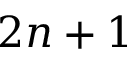Convert formula to latex. <formula><loc_0><loc_0><loc_500><loc_500>2 n + 1</formula> 